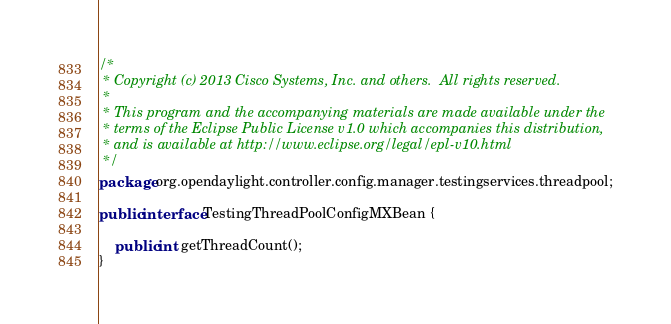Convert code to text. <code><loc_0><loc_0><loc_500><loc_500><_Java_>/*
 * Copyright (c) 2013 Cisco Systems, Inc. and others.  All rights reserved.
 *
 * This program and the accompanying materials are made available under the
 * terms of the Eclipse Public License v1.0 which accompanies this distribution,
 * and is available at http://www.eclipse.org/legal/epl-v10.html
 */
package org.opendaylight.controller.config.manager.testingservices.threadpool;

public interface TestingThreadPoolConfigMXBean {

    public int getThreadCount();
}
</code> 